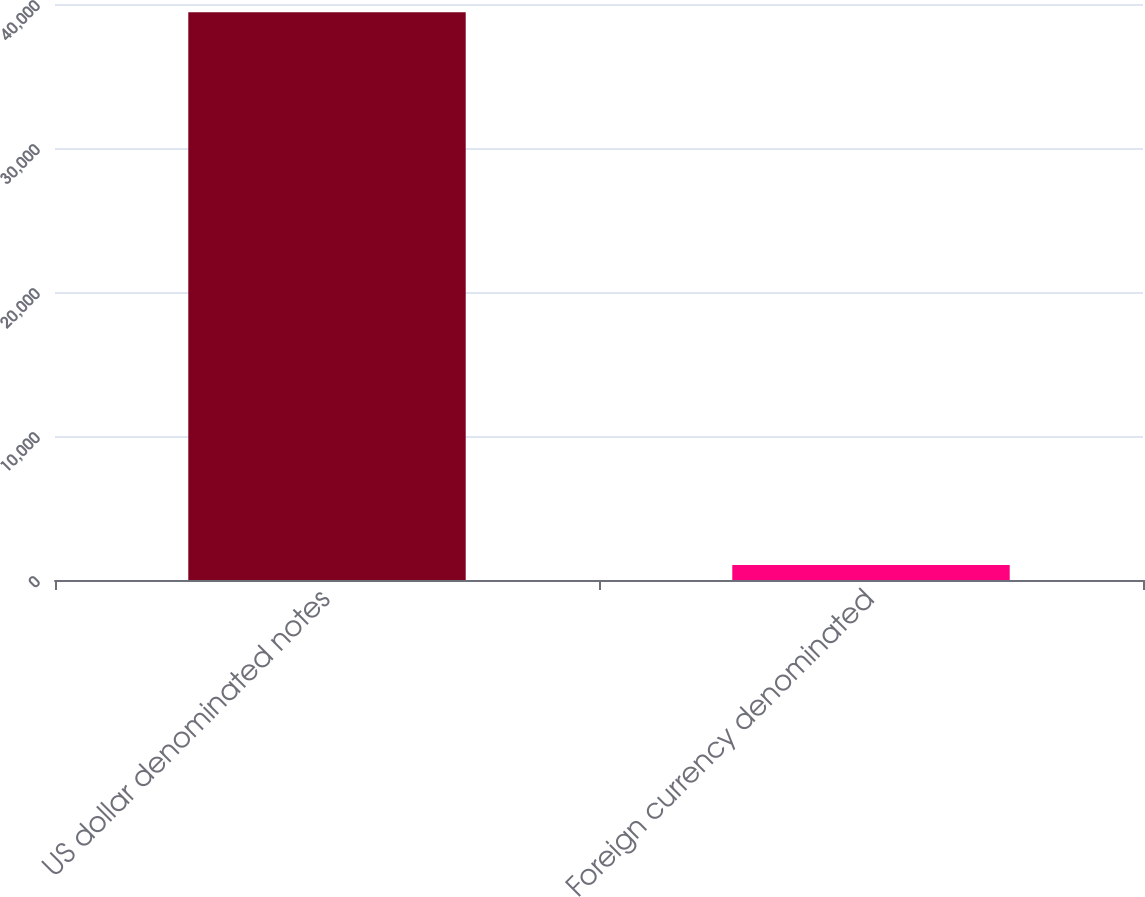Convert chart to OTSL. <chart><loc_0><loc_0><loc_500><loc_500><bar_chart><fcel>US dollar denominated notes<fcel>Foreign currency denominated<nl><fcel>39424<fcel>1044<nl></chart> 